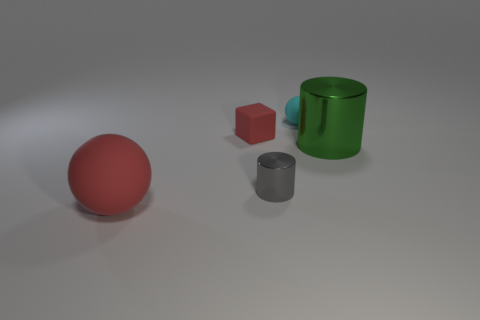Does the red rubber thing in front of the tiny gray metal object have the same shape as the tiny gray thing?
Provide a succinct answer. No. What number of red balls have the same size as the gray shiny cylinder?
Your answer should be very brief. 0. There is a matte thing that is the same color as the rubber cube; what shape is it?
Ensure brevity in your answer.  Sphere. There is a metallic cylinder right of the cyan matte ball; are there any gray shiny cylinders that are to the right of it?
Provide a succinct answer. No. How many things are large rubber spheres that are on the left side of the tiny cyan object or big purple rubber objects?
Your response must be concise. 1. How many large rubber things are there?
Provide a short and direct response. 1. What is the shape of the other thing that is made of the same material as the gray object?
Offer a very short reply. Cylinder. There is a rubber sphere in front of the red matte thing that is to the right of the large sphere; what is its size?
Give a very brief answer. Large. What number of objects are either matte balls that are to the right of the big red object or tiny red objects that are behind the red sphere?
Make the answer very short. 2. Are there fewer small cubes than cylinders?
Your answer should be very brief. Yes. 